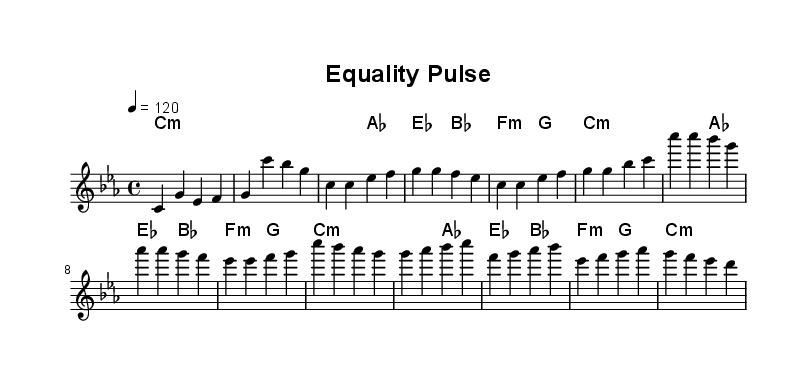What is the key signature of this music? The key signature is C minor, which has three flats: B flat, E flat, and A flat.
Answer: C minor What is the time signature of the piece? The time signature is indicated as 4/4, meaning there are four beats in a measure, and the quarter note gets one beat.
Answer: 4/4 What is the tempo marking of the music? The tempo is marked at quarter note equals 120 beats per minute, indicating a moderately fast tempo.
Answer: 120 How many measures are there in the chorus section? By counting the measures indicated in the chorus, there are four distinct measures present.
Answer: 4 What type of chords are predominantly used throughout the piece? The chords used are primarily minor chords, as indicated by the 'm' notation in the chord changes.
Answer: Minor What is the primary theme of the music based on its title and content? The title "Equality Pulse" suggests a focus on social justice and equality, reflected in the music's thematic elements and lyrical intent.
Answer: Social justice How does the melody relate to the harmonies in the verse section? The melody notes align with the harmonies designated, showcasing a supportive relationship where each chord complements the corresponding melodic note.
Answer: Complementary 